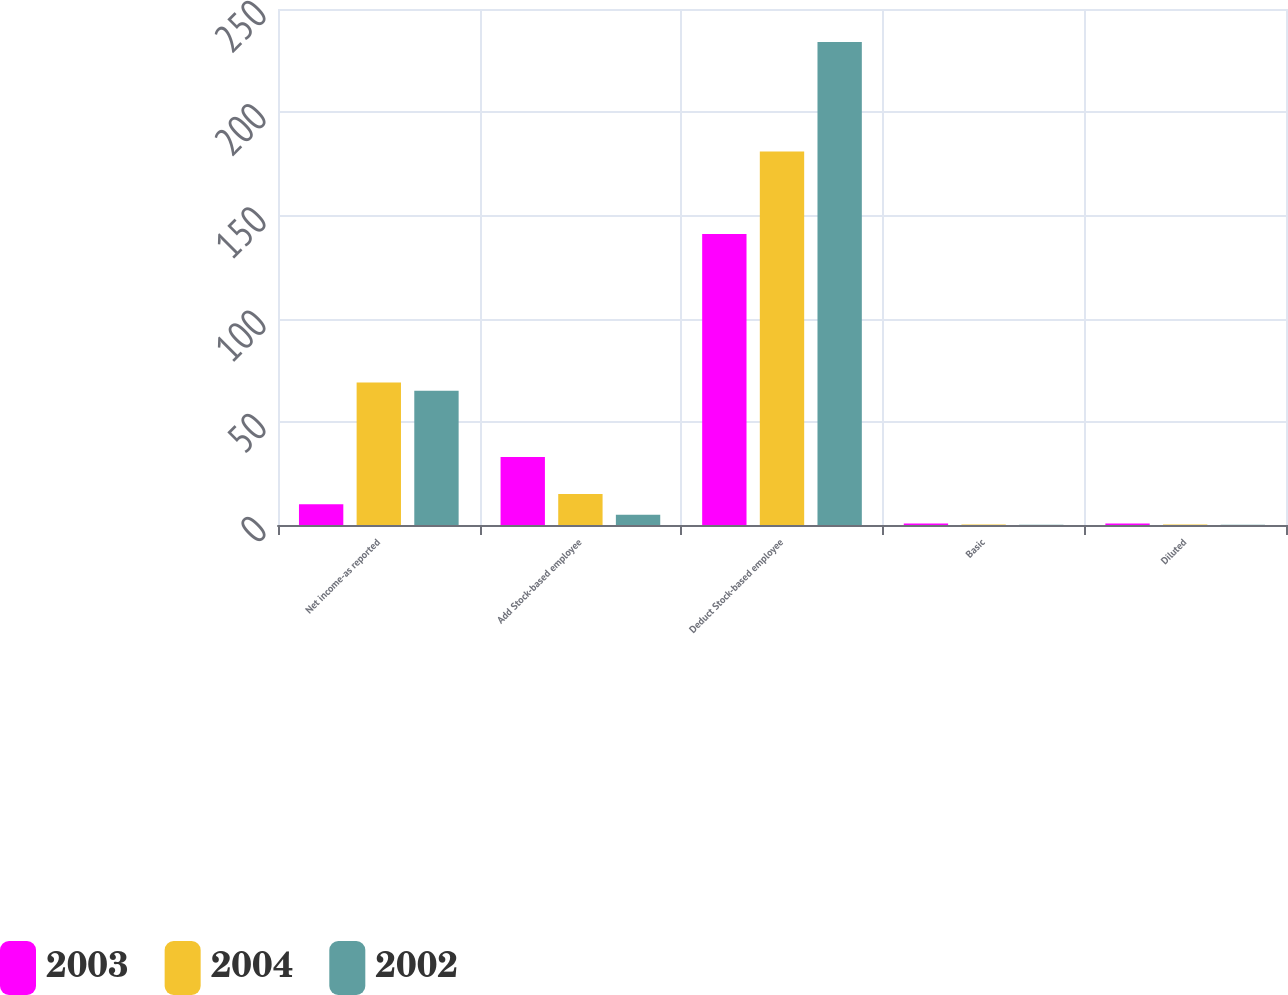Convert chart to OTSL. <chart><loc_0><loc_0><loc_500><loc_500><stacked_bar_chart><ecel><fcel>Net income-as reported<fcel>Add Stock-based employee<fcel>Deduct Stock-based employee<fcel>Basic<fcel>Diluted<nl><fcel>2003<fcel>10<fcel>33<fcel>141<fcel>0.74<fcel>0.71<nl><fcel>2004<fcel>69<fcel>15<fcel>181<fcel>0.19<fcel>0.19<nl><fcel>2002<fcel>65<fcel>5<fcel>234<fcel>0.18<fcel>0.18<nl></chart> 